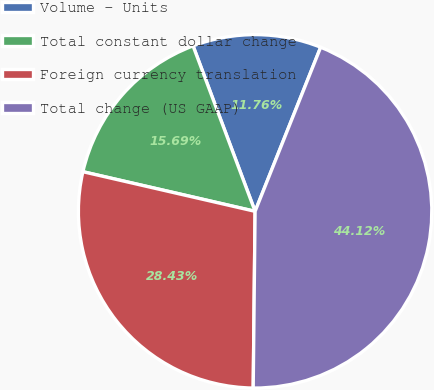Convert chart. <chart><loc_0><loc_0><loc_500><loc_500><pie_chart><fcel>Volume - Units<fcel>Total constant dollar change<fcel>Foreign currency translation<fcel>Total change (US GAAP)<nl><fcel>11.76%<fcel>15.69%<fcel>28.43%<fcel>44.12%<nl></chart> 